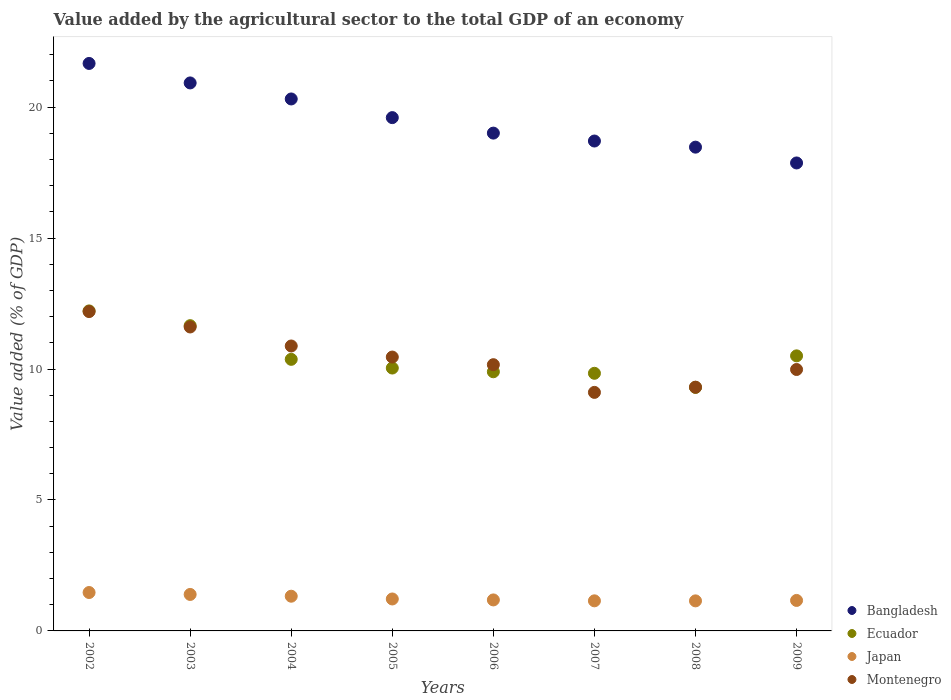Is the number of dotlines equal to the number of legend labels?
Give a very brief answer. Yes. What is the value added by the agricultural sector to the total GDP in Montenegro in 2008?
Your response must be concise. 9.31. Across all years, what is the maximum value added by the agricultural sector to the total GDP in Montenegro?
Keep it short and to the point. 12.19. Across all years, what is the minimum value added by the agricultural sector to the total GDP in Montenegro?
Keep it short and to the point. 9.11. In which year was the value added by the agricultural sector to the total GDP in Japan minimum?
Ensure brevity in your answer.  2008. What is the total value added by the agricultural sector to the total GDP in Montenegro in the graph?
Offer a terse response. 83.7. What is the difference between the value added by the agricultural sector to the total GDP in Montenegro in 2003 and that in 2006?
Ensure brevity in your answer.  1.44. What is the difference between the value added by the agricultural sector to the total GDP in Montenegro in 2004 and the value added by the agricultural sector to the total GDP in Bangladesh in 2009?
Keep it short and to the point. -6.99. What is the average value added by the agricultural sector to the total GDP in Ecuador per year?
Your answer should be very brief. 10.48. In the year 2008, what is the difference between the value added by the agricultural sector to the total GDP in Bangladesh and value added by the agricultural sector to the total GDP in Japan?
Your answer should be very brief. 17.32. What is the ratio of the value added by the agricultural sector to the total GDP in Montenegro in 2002 to that in 2006?
Make the answer very short. 1.2. Is the difference between the value added by the agricultural sector to the total GDP in Bangladesh in 2002 and 2009 greater than the difference between the value added by the agricultural sector to the total GDP in Japan in 2002 and 2009?
Give a very brief answer. Yes. What is the difference between the highest and the second highest value added by the agricultural sector to the total GDP in Japan?
Make the answer very short. 0.07. What is the difference between the highest and the lowest value added by the agricultural sector to the total GDP in Montenegro?
Offer a terse response. 3.09. In how many years, is the value added by the agricultural sector to the total GDP in Ecuador greater than the average value added by the agricultural sector to the total GDP in Ecuador taken over all years?
Your answer should be compact. 3. Is the sum of the value added by the agricultural sector to the total GDP in Bangladesh in 2003 and 2004 greater than the maximum value added by the agricultural sector to the total GDP in Japan across all years?
Your response must be concise. Yes. Is it the case that in every year, the sum of the value added by the agricultural sector to the total GDP in Bangladesh and value added by the agricultural sector to the total GDP in Montenegro  is greater than the sum of value added by the agricultural sector to the total GDP in Ecuador and value added by the agricultural sector to the total GDP in Japan?
Offer a terse response. Yes. Does the value added by the agricultural sector to the total GDP in Ecuador monotonically increase over the years?
Provide a short and direct response. No. How many dotlines are there?
Give a very brief answer. 4. What is the difference between two consecutive major ticks on the Y-axis?
Keep it short and to the point. 5. Does the graph contain grids?
Ensure brevity in your answer.  No. Where does the legend appear in the graph?
Provide a succinct answer. Bottom right. How many legend labels are there?
Your answer should be very brief. 4. How are the legend labels stacked?
Provide a short and direct response. Vertical. What is the title of the graph?
Make the answer very short. Value added by the agricultural sector to the total GDP of an economy. What is the label or title of the X-axis?
Your response must be concise. Years. What is the label or title of the Y-axis?
Ensure brevity in your answer.  Value added (% of GDP). What is the Value added (% of GDP) in Bangladesh in 2002?
Your answer should be compact. 21.67. What is the Value added (% of GDP) of Ecuador in 2002?
Keep it short and to the point. 12.22. What is the Value added (% of GDP) in Japan in 2002?
Offer a terse response. 1.47. What is the Value added (% of GDP) in Montenegro in 2002?
Keep it short and to the point. 12.19. What is the Value added (% of GDP) of Bangladesh in 2003?
Make the answer very short. 20.92. What is the Value added (% of GDP) in Ecuador in 2003?
Make the answer very short. 11.66. What is the Value added (% of GDP) of Japan in 2003?
Your response must be concise. 1.39. What is the Value added (% of GDP) in Montenegro in 2003?
Ensure brevity in your answer.  11.61. What is the Value added (% of GDP) in Bangladesh in 2004?
Offer a very short reply. 20.31. What is the Value added (% of GDP) of Ecuador in 2004?
Ensure brevity in your answer.  10.37. What is the Value added (% of GDP) in Japan in 2004?
Offer a very short reply. 1.33. What is the Value added (% of GDP) of Montenegro in 2004?
Ensure brevity in your answer.  10.88. What is the Value added (% of GDP) of Bangladesh in 2005?
Ensure brevity in your answer.  19.6. What is the Value added (% of GDP) of Ecuador in 2005?
Ensure brevity in your answer.  10.04. What is the Value added (% of GDP) in Japan in 2005?
Keep it short and to the point. 1.22. What is the Value added (% of GDP) of Montenegro in 2005?
Offer a very short reply. 10.46. What is the Value added (% of GDP) in Bangladesh in 2006?
Offer a very short reply. 19.01. What is the Value added (% of GDP) of Ecuador in 2006?
Keep it short and to the point. 9.9. What is the Value added (% of GDP) in Japan in 2006?
Make the answer very short. 1.18. What is the Value added (% of GDP) of Montenegro in 2006?
Your answer should be very brief. 10.17. What is the Value added (% of GDP) of Bangladesh in 2007?
Your response must be concise. 18.71. What is the Value added (% of GDP) of Ecuador in 2007?
Keep it short and to the point. 9.84. What is the Value added (% of GDP) of Japan in 2007?
Your answer should be very brief. 1.15. What is the Value added (% of GDP) in Montenegro in 2007?
Provide a succinct answer. 9.11. What is the Value added (% of GDP) of Bangladesh in 2008?
Offer a terse response. 18.47. What is the Value added (% of GDP) of Ecuador in 2008?
Offer a very short reply. 9.3. What is the Value added (% of GDP) in Japan in 2008?
Provide a succinct answer. 1.15. What is the Value added (% of GDP) in Montenegro in 2008?
Keep it short and to the point. 9.31. What is the Value added (% of GDP) in Bangladesh in 2009?
Your answer should be compact. 17.87. What is the Value added (% of GDP) in Ecuador in 2009?
Provide a short and direct response. 10.5. What is the Value added (% of GDP) in Japan in 2009?
Offer a very short reply. 1.16. What is the Value added (% of GDP) of Montenegro in 2009?
Your answer should be compact. 9.98. Across all years, what is the maximum Value added (% of GDP) of Bangladesh?
Make the answer very short. 21.67. Across all years, what is the maximum Value added (% of GDP) of Ecuador?
Ensure brevity in your answer.  12.22. Across all years, what is the maximum Value added (% of GDP) in Japan?
Offer a terse response. 1.47. Across all years, what is the maximum Value added (% of GDP) in Montenegro?
Offer a very short reply. 12.19. Across all years, what is the minimum Value added (% of GDP) of Bangladesh?
Offer a very short reply. 17.87. Across all years, what is the minimum Value added (% of GDP) of Ecuador?
Offer a terse response. 9.3. Across all years, what is the minimum Value added (% of GDP) in Japan?
Make the answer very short. 1.15. Across all years, what is the minimum Value added (% of GDP) of Montenegro?
Provide a short and direct response. 9.11. What is the total Value added (% of GDP) in Bangladesh in the graph?
Provide a short and direct response. 156.56. What is the total Value added (% of GDP) in Ecuador in the graph?
Your answer should be compact. 83.82. What is the total Value added (% of GDP) in Japan in the graph?
Ensure brevity in your answer.  10.05. What is the total Value added (% of GDP) of Montenegro in the graph?
Offer a terse response. 83.7. What is the difference between the Value added (% of GDP) in Bangladesh in 2002 and that in 2003?
Give a very brief answer. 0.74. What is the difference between the Value added (% of GDP) in Ecuador in 2002 and that in 2003?
Provide a short and direct response. 0.56. What is the difference between the Value added (% of GDP) of Japan in 2002 and that in 2003?
Your answer should be compact. 0.07. What is the difference between the Value added (% of GDP) in Montenegro in 2002 and that in 2003?
Ensure brevity in your answer.  0.59. What is the difference between the Value added (% of GDP) of Bangladesh in 2002 and that in 2004?
Provide a succinct answer. 1.36. What is the difference between the Value added (% of GDP) in Ecuador in 2002 and that in 2004?
Provide a succinct answer. 1.85. What is the difference between the Value added (% of GDP) of Japan in 2002 and that in 2004?
Provide a short and direct response. 0.14. What is the difference between the Value added (% of GDP) of Montenegro in 2002 and that in 2004?
Your response must be concise. 1.31. What is the difference between the Value added (% of GDP) of Bangladesh in 2002 and that in 2005?
Keep it short and to the point. 2.07. What is the difference between the Value added (% of GDP) of Ecuador in 2002 and that in 2005?
Provide a short and direct response. 2.18. What is the difference between the Value added (% of GDP) of Japan in 2002 and that in 2005?
Offer a terse response. 0.25. What is the difference between the Value added (% of GDP) of Montenegro in 2002 and that in 2005?
Provide a succinct answer. 1.74. What is the difference between the Value added (% of GDP) in Bangladesh in 2002 and that in 2006?
Keep it short and to the point. 2.66. What is the difference between the Value added (% of GDP) of Ecuador in 2002 and that in 2006?
Your answer should be very brief. 2.32. What is the difference between the Value added (% of GDP) in Japan in 2002 and that in 2006?
Offer a very short reply. 0.28. What is the difference between the Value added (% of GDP) in Montenegro in 2002 and that in 2006?
Give a very brief answer. 2.03. What is the difference between the Value added (% of GDP) in Bangladesh in 2002 and that in 2007?
Your answer should be compact. 2.96. What is the difference between the Value added (% of GDP) of Ecuador in 2002 and that in 2007?
Provide a succinct answer. 2.38. What is the difference between the Value added (% of GDP) of Japan in 2002 and that in 2007?
Your response must be concise. 0.32. What is the difference between the Value added (% of GDP) of Montenegro in 2002 and that in 2007?
Provide a succinct answer. 3.09. What is the difference between the Value added (% of GDP) in Bangladesh in 2002 and that in 2008?
Your answer should be compact. 3.2. What is the difference between the Value added (% of GDP) in Ecuador in 2002 and that in 2008?
Offer a terse response. 2.92. What is the difference between the Value added (% of GDP) of Japan in 2002 and that in 2008?
Ensure brevity in your answer.  0.32. What is the difference between the Value added (% of GDP) in Montenegro in 2002 and that in 2008?
Your answer should be compact. 2.89. What is the difference between the Value added (% of GDP) of Bangladesh in 2002 and that in 2009?
Your answer should be compact. 3.8. What is the difference between the Value added (% of GDP) in Ecuador in 2002 and that in 2009?
Offer a very short reply. 1.72. What is the difference between the Value added (% of GDP) in Japan in 2002 and that in 2009?
Make the answer very short. 0.3. What is the difference between the Value added (% of GDP) of Montenegro in 2002 and that in 2009?
Your answer should be very brief. 2.21. What is the difference between the Value added (% of GDP) in Bangladesh in 2003 and that in 2004?
Provide a short and direct response. 0.61. What is the difference between the Value added (% of GDP) of Ecuador in 2003 and that in 2004?
Make the answer very short. 1.29. What is the difference between the Value added (% of GDP) of Japan in 2003 and that in 2004?
Your response must be concise. 0.07. What is the difference between the Value added (% of GDP) of Montenegro in 2003 and that in 2004?
Your answer should be compact. 0.73. What is the difference between the Value added (% of GDP) in Bangladesh in 2003 and that in 2005?
Ensure brevity in your answer.  1.32. What is the difference between the Value added (% of GDP) in Ecuador in 2003 and that in 2005?
Offer a terse response. 1.62. What is the difference between the Value added (% of GDP) of Japan in 2003 and that in 2005?
Ensure brevity in your answer.  0.17. What is the difference between the Value added (% of GDP) of Montenegro in 2003 and that in 2005?
Offer a very short reply. 1.15. What is the difference between the Value added (% of GDP) of Bangladesh in 2003 and that in 2006?
Your response must be concise. 1.92. What is the difference between the Value added (% of GDP) in Ecuador in 2003 and that in 2006?
Provide a short and direct response. 1.76. What is the difference between the Value added (% of GDP) in Japan in 2003 and that in 2006?
Your answer should be very brief. 0.21. What is the difference between the Value added (% of GDP) in Montenegro in 2003 and that in 2006?
Provide a succinct answer. 1.44. What is the difference between the Value added (% of GDP) of Bangladesh in 2003 and that in 2007?
Offer a very short reply. 2.22. What is the difference between the Value added (% of GDP) in Ecuador in 2003 and that in 2007?
Keep it short and to the point. 1.82. What is the difference between the Value added (% of GDP) in Japan in 2003 and that in 2007?
Your response must be concise. 0.24. What is the difference between the Value added (% of GDP) in Montenegro in 2003 and that in 2007?
Keep it short and to the point. 2.5. What is the difference between the Value added (% of GDP) of Bangladesh in 2003 and that in 2008?
Provide a short and direct response. 2.45. What is the difference between the Value added (% of GDP) in Ecuador in 2003 and that in 2008?
Your response must be concise. 2.36. What is the difference between the Value added (% of GDP) in Japan in 2003 and that in 2008?
Ensure brevity in your answer.  0.25. What is the difference between the Value added (% of GDP) of Montenegro in 2003 and that in 2008?
Your response must be concise. 2.3. What is the difference between the Value added (% of GDP) in Bangladesh in 2003 and that in 2009?
Keep it short and to the point. 3.06. What is the difference between the Value added (% of GDP) in Ecuador in 2003 and that in 2009?
Ensure brevity in your answer.  1.15. What is the difference between the Value added (% of GDP) of Japan in 2003 and that in 2009?
Provide a succinct answer. 0.23. What is the difference between the Value added (% of GDP) of Montenegro in 2003 and that in 2009?
Ensure brevity in your answer.  1.62. What is the difference between the Value added (% of GDP) in Bangladesh in 2004 and that in 2005?
Offer a terse response. 0.71. What is the difference between the Value added (% of GDP) in Ecuador in 2004 and that in 2005?
Make the answer very short. 0.33. What is the difference between the Value added (% of GDP) of Japan in 2004 and that in 2005?
Give a very brief answer. 0.11. What is the difference between the Value added (% of GDP) of Montenegro in 2004 and that in 2005?
Offer a terse response. 0.42. What is the difference between the Value added (% of GDP) in Bangladesh in 2004 and that in 2006?
Provide a short and direct response. 1.3. What is the difference between the Value added (% of GDP) of Ecuador in 2004 and that in 2006?
Your response must be concise. 0.47. What is the difference between the Value added (% of GDP) of Japan in 2004 and that in 2006?
Your answer should be compact. 0.14. What is the difference between the Value added (% of GDP) in Montenegro in 2004 and that in 2006?
Your response must be concise. 0.71. What is the difference between the Value added (% of GDP) in Bangladesh in 2004 and that in 2007?
Keep it short and to the point. 1.61. What is the difference between the Value added (% of GDP) of Ecuador in 2004 and that in 2007?
Provide a short and direct response. 0.53. What is the difference between the Value added (% of GDP) of Japan in 2004 and that in 2007?
Ensure brevity in your answer.  0.18. What is the difference between the Value added (% of GDP) in Montenegro in 2004 and that in 2007?
Ensure brevity in your answer.  1.77. What is the difference between the Value added (% of GDP) of Bangladesh in 2004 and that in 2008?
Offer a terse response. 1.84. What is the difference between the Value added (% of GDP) of Ecuador in 2004 and that in 2008?
Your answer should be compact. 1.07. What is the difference between the Value added (% of GDP) of Japan in 2004 and that in 2008?
Make the answer very short. 0.18. What is the difference between the Value added (% of GDP) in Montenegro in 2004 and that in 2008?
Your answer should be very brief. 1.57. What is the difference between the Value added (% of GDP) of Bangladesh in 2004 and that in 2009?
Your answer should be very brief. 2.44. What is the difference between the Value added (% of GDP) in Ecuador in 2004 and that in 2009?
Your response must be concise. -0.13. What is the difference between the Value added (% of GDP) in Japan in 2004 and that in 2009?
Ensure brevity in your answer.  0.16. What is the difference between the Value added (% of GDP) in Montenegro in 2004 and that in 2009?
Ensure brevity in your answer.  0.9. What is the difference between the Value added (% of GDP) of Bangladesh in 2005 and that in 2006?
Offer a very short reply. 0.59. What is the difference between the Value added (% of GDP) of Ecuador in 2005 and that in 2006?
Your answer should be compact. 0.14. What is the difference between the Value added (% of GDP) in Japan in 2005 and that in 2006?
Your answer should be compact. 0.04. What is the difference between the Value added (% of GDP) in Montenegro in 2005 and that in 2006?
Ensure brevity in your answer.  0.29. What is the difference between the Value added (% of GDP) of Bangladesh in 2005 and that in 2007?
Provide a short and direct response. 0.89. What is the difference between the Value added (% of GDP) of Ecuador in 2005 and that in 2007?
Provide a succinct answer. 0.2. What is the difference between the Value added (% of GDP) in Japan in 2005 and that in 2007?
Your response must be concise. 0.07. What is the difference between the Value added (% of GDP) of Montenegro in 2005 and that in 2007?
Give a very brief answer. 1.35. What is the difference between the Value added (% of GDP) in Bangladesh in 2005 and that in 2008?
Give a very brief answer. 1.13. What is the difference between the Value added (% of GDP) in Ecuador in 2005 and that in 2008?
Keep it short and to the point. 0.74. What is the difference between the Value added (% of GDP) of Japan in 2005 and that in 2008?
Provide a succinct answer. 0.07. What is the difference between the Value added (% of GDP) in Montenegro in 2005 and that in 2008?
Ensure brevity in your answer.  1.15. What is the difference between the Value added (% of GDP) of Bangladesh in 2005 and that in 2009?
Keep it short and to the point. 1.73. What is the difference between the Value added (% of GDP) of Ecuador in 2005 and that in 2009?
Ensure brevity in your answer.  -0.47. What is the difference between the Value added (% of GDP) in Japan in 2005 and that in 2009?
Your response must be concise. 0.06. What is the difference between the Value added (% of GDP) in Montenegro in 2005 and that in 2009?
Give a very brief answer. 0.47. What is the difference between the Value added (% of GDP) in Bangladesh in 2006 and that in 2007?
Keep it short and to the point. 0.3. What is the difference between the Value added (% of GDP) in Ecuador in 2006 and that in 2007?
Your response must be concise. 0.06. What is the difference between the Value added (% of GDP) of Japan in 2006 and that in 2007?
Your answer should be compact. 0.03. What is the difference between the Value added (% of GDP) of Montenegro in 2006 and that in 2007?
Give a very brief answer. 1.06. What is the difference between the Value added (% of GDP) of Bangladesh in 2006 and that in 2008?
Provide a short and direct response. 0.54. What is the difference between the Value added (% of GDP) of Ecuador in 2006 and that in 2008?
Provide a short and direct response. 0.6. What is the difference between the Value added (% of GDP) in Japan in 2006 and that in 2008?
Give a very brief answer. 0.04. What is the difference between the Value added (% of GDP) of Montenegro in 2006 and that in 2008?
Your response must be concise. 0.86. What is the difference between the Value added (% of GDP) of Bangladesh in 2006 and that in 2009?
Your answer should be compact. 1.14. What is the difference between the Value added (% of GDP) of Ecuador in 2006 and that in 2009?
Offer a terse response. -0.61. What is the difference between the Value added (% of GDP) in Japan in 2006 and that in 2009?
Ensure brevity in your answer.  0.02. What is the difference between the Value added (% of GDP) in Montenegro in 2006 and that in 2009?
Offer a terse response. 0.18. What is the difference between the Value added (% of GDP) in Bangladesh in 2007 and that in 2008?
Your answer should be very brief. 0.23. What is the difference between the Value added (% of GDP) in Ecuador in 2007 and that in 2008?
Make the answer very short. 0.54. What is the difference between the Value added (% of GDP) in Japan in 2007 and that in 2008?
Ensure brevity in your answer.  0. What is the difference between the Value added (% of GDP) of Montenegro in 2007 and that in 2008?
Offer a terse response. -0.2. What is the difference between the Value added (% of GDP) of Bangladesh in 2007 and that in 2009?
Give a very brief answer. 0.84. What is the difference between the Value added (% of GDP) of Ecuador in 2007 and that in 2009?
Make the answer very short. -0.67. What is the difference between the Value added (% of GDP) of Japan in 2007 and that in 2009?
Keep it short and to the point. -0.02. What is the difference between the Value added (% of GDP) in Montenegro in 2007 and that in 2009?
Make the answer very short. -0.87. What is the difference between the Value added (% of GDP) of Bangladesh in 2008 and that in 2009?
Ensure brevity in your answer.  0.6. What is the difference between the Value added (% of GDP) in Ecuador in 2008 and that in 2009?
Give a very brief answer. -1.2. What is the difference between the Value added (% of GDP) of Japan in 2008 and that in 2009?
Offer a very short reply. -0.02. What is the difference between the Value added (% of GDP) in Montenegro in 2008 and that in 2009?
Offer a terse response. -0.68. What is the difference between the Value added (% of GDP) of Bangladesh in 2002 and the Value added (% of GDP) of Ecuador in 2003?
Your answer should be very brief. 10.01. What is the difference between the Value added (% of GDP) of Bangladesh in 2002 and the Value added (% of GDP) of Japan in 2003?
Provide a succinct answer. 20.28. What is the difference between the Value added (% of GDP) of Bangladesh in 2002 and the Value added (% of GDP) of Montenegro in 2003?
Keep it short and to the point. 10.06. What is the difference between the Value added (% of GDP) in Ecuador in 2002 and the Value added (% of GDP) in Japan in 2003?
Provide a short and direct response. 10.83. What is the difference between the Value added (% of GDP) of Ecuador in 2002 and the Value added (% of GDP) of Montenegro in 2003?
Your response must be concise. 0.61. What is the difference between the Value added (% of GDP) of Japan in 2002 and the Value added (% of GDP) of Montenegro in 2003?
Your answer should be very brief. -10.14. What is the difference between the Value added (% of GDP) in Bangladesh in 2002 and the Value added (% of GDP) in Ecuador in 2004?
Keep it short and to the point. 11.3. What is the difference between the Value added (% of GDP) in Bangladesh in 2002 and the Value added (% of GDP) in Japan in 2004?
Provide a succinct answer. 20.34. What is the difference between the Value added (% of GDP) in Bangladesh in 2002 and the Value added (% of GDP) in Montenegro in 2004?
Give a very brief answer. 10.79. What is the difference between the Value added (% of GDP) of Ecuador in 2002 and the Value added (% of GDP) of Japan in 2004?
Provide a short and direct response. 10.89. What is the difference between the Value added (% of GDP) of Ecuador in 2002 and the Value added (% of GDP) of Montenegro in 2004?
Make the answer very short. 1.34. What is the difference between the Value added (% of GDP) in Japan in 2002 and the Value added (% of GDP) in Montenegro in 2004?
Ensure brevity in your answer.  -9.41. What is the difference between the Value added (% of GDP) in Bangladesh in 2002 and the Value added (% of GDP) in Ecuador in 2005?
Provide a succinct answer. 11.63. What is the difference between the Value added (% of GDP) of Bangladesh in 2002 and the Value added (% of GDP) of Japan in 2005?
Provide a succinct answer. 20.45. What is the difference between the Value added (% of GDP) in Bangladesh in 2002 and the Value added (% of GDP) in Montenegro in 2005?
Give a very brief answer. 11.21. What is the difference between the Value added (% of GDP) of Ecuador in 2002 and the Value added (% of GDP) of Japan in 2005?
Your answer should be compact. 11. What is the difference between the Value added (% of GDP) in Ecuador in 2002 and the Value added (% of GDP) in Montenegro in 2005?
Offer a very short reply. 1.76. What is the difference between the Value added (% of GDP) in Japan in 2002 and the Value added (% of GDP) in Montenegro in 2005?
Your response must be concise. -8.99. What is the difference between the Value added (% of GDP) in Bangladesh in 2002 and the Value added (% of GDP) in Ecuador in 2006?
Provide a succinct answer. 11.77. What is the difference between the Value added (% of GDP) in Bangladesh in 2002 and the Value added (% of GDP) in Japan in 2006?
Offer a very short reply. 20.48. What is the difference between the Value added (% of GDP) of Bangladesh in 2002 and the Value added (% of GDP) of Montenegro in 2006?
Keep it short and to the point. 11.5. What is the difference between the Value added (% of GDP) of Ecuador in 2002 and the Value added (% of GDP) of Japan in 2006?
Keep it short and to the point. 11.04. What is the difference between the Value added (% of GDP) in Ecuador in 2002 and the Value added (% of GDP) in Montenegro in 2006?
Provide a succinct answer. 2.05. What is the difference between the Value added (% of GDP) of Japan in 2002 and the Value added (% of GDP) of Montenegro in 2006?
Offer a very short reply. -8.7. What is the difference between the Value added (% of GDP) in Bangladesh in 2002 and the Value added (% of GDP) in Ecuador in 2007?
Your answer should be very brief. 11.83. What is the difference between the Value added (% of GDP) in Bangladesh in 2002 and the Value added (% of GDP) in Japan in 2007?
Offer a very short reply. 20.52. What is the difference between the Value added (% of GDP) in Bangladesh in 2002 and the Value added (% of GDP) in Montenegro in 2007?
Your response must be concise. 12.56. What is the difference between the Value added (% of GDP) of Ecuador in 2002 and the Value added (% of GDP) of Japan in 2007?
Ensure brevity in your answer.  11.07. What is the difference between the Value added (% of GDP) of Ecuador in 2002 and the Value added (% of GDP) of Montenegro in 2007?
Give a very brief answer. 3.11. What is the difference between the Value added (% of GDP) of Japan in 2002 and the Value added (% of GDP) of Montenegro in 2007?
Provide a succinct answer. -7.64. What is the difference between the Value added (% of GDP) of Bangladesh in 2002 and the Value added (% of GDP) of Ecuador in 2008?
Offer a terse response. 12.37. What is the difference between the Value added (% of GDP) of Bangladesh in 2002 and the Value added (% of GDP) of Japan in 2008?
Give a very brief answer. 20.52. What is the difference between the Value added (% of GDP) in Bangladesh in 2002 and the Value added (% of GDP) in Montenegro in 2008?
Offer a very short reply. 12.36. What is the difference between the Value added (% of GDP) in Ecuador in 2002 and the Value added (% of GDP) in Japan in 2008?
Offer a terse response. 11.07. What is the difference between the Value added (% of GDP) in Ecuador in 2002 and the Value added (% of GDP) in Montenegro in 2008?
Your answer should be very brief. 2.91. What is the difference between the Value added (% of GDP) in Japan in 2002 and the Value added (% of GDP) in Montenegro in 2008?
Offer a terse response. -7.84. What is the difference between the Value added (% of GDP) of Bangladesh in 2002 and the Value added (% of GDP) of Ecuador in 2009?
Make the answer very short. 11.17. What is the difference between the Value added (% of GDP) of Bangladesh in 2002 and the Value added (% of GDP) of Japan in 2009?
Offer a terse response. 20.5. What is the difference between the Value added (% of GDP) of Bangladesh in 2002 and the Value added (% of GDP) of Montenegro in 2009?
Your answer should be very brief. 11.69. What is the difference between the Value added (% of GDP) of Ecuador in 2002 and the Value added (% of GDP) of Japan in 2009?
Keep it short and to the point. 11.06. What is the difference between the Value added (% of GDP) in Ecuador in 2002 and the Value added (% of GDP) in Montenegro in 2009?
Offer a terse response. 2.24. What is the difference between the Value added (% of GDP) in Japan in 2002 and the Value added (% of GDP) in Montenegro in 2009?
Offer a very short reply. -8.52. What is the difference between the Value added (% of GDP) in Bangladesh in 2003 and the Value added (% of GDP) in Ecuador in 2004?
Make the answer very short. 10.55. What is the difference between the Value added (% of GDP) in Bangladesh in 2003 and the Value added (% of GDP) in Japan in 2004?
Your response must be concise. 19.6. What is the difference between the Value added (% of GDP) of Bangladesh in 2003 and the Value added (% of GDP) of Montenegro in 2004?
Provide a succinct answer. 10.04. What is the difference between the Value added (% of GDP) of Ecuador in 2003 and the Value added (% of GDP) of Japan in 2004?
Offer a very short reply. 10.33. What is the difference between the Value added (% of GDP) in Ecuador in 2003 and the Value added (% of GDP) in Montenegro in 2004?
Provide a short and direct response. 0.78. What is the difference between the Value added (% of GDP) of Japan in 2003 and the Value added (% of GDP) of Montenegro in 2004?
Offer a terse response. -9.49. What is the difference between the Value added (% of GDP) of Bangladesh in 2003 and the Value added (% of GDP) of Ecuador in 2005?
Provide a succinct answer. 10.89. What is the difference between the Value added (% of GDP) in Bangladesh in 2003 and the Value added (% of GDP) in Japan in 2005?
Make the answer very short. 19.7. What is the difference between the Value added (% of GDP) in Bangladesh in 2003 and the Value added (% of GDP) in Montenegro in 2005?
Keep it short and to the point. 10.47. What is the difference between the Value added (% of GDP) in Ecuador in 2003 and the Value added (% of GDP) in Japan in 2005?
Give a very brief answer. 10.44. What is the difference between the Value added (% of GDP) in Ecuador in 2003 and the Value added (% of GDP) in Montenegro in 2005?
Give a very brief answer. 1.2. What is the difference between the Value added (% of GDP) in Japan in 2003 and the Value added (% of GDP) in Montenegro in 2005?
Keep it short and to the point. -9.06. What is the difference between the Value added (% of GDP) in Bangladesh in 2003 and the Value added (% of GDP) in Ecuador in 2006?
Offer a terse response. 11.03. What is the difference between the Value added (% of GDP) of Bangladesh in 2003 and the Value added (% of GDP) of Japan in 2006?
Offer a very short reply. 19.74. What is the difference between the Value added (% of GDP) of Bangladesh in 2003 and the Value added (% of GDP) of Montenegro in 2006?
Keep it short and to the point. 10.76. What is the difference between the Value added (% of GDP) in Ecuador in 2003 and the Value added (% of GDP) in Japan in 2006?
Provide a succinct answer. 10.47. What is the difference between the Value added (% of GDP) of Ecuador in 2003 and the Value added (% of GDP) of Montenegro in 2006?
Your response must be concise. 1.49. What is the difference between the Value added (% of GDP) of Japan in 2003 and the Value added (% of GDP) of Montenegro in 2006?
Make the answer very short. -8.77. What is the difference between the Value added (% of GDP) of Bangladesh in 2003 and the Value added (% of GDP) of Ecuador in 2007?
Give a very brief answer. 11.09. What is the difference between the Value added (% of GDP) of Bangladesh in 2003 and the Value added (% of GDP) of Japan in 2007?
Ensure brevity in your answer.  19.78. What is the difference between the Value added (% of GDP) of Bangladesh in 2003 and the Value added (% of GDP) of Montenegro in 2007?
Ensure brevity in your answer.  11.82. What is the difference between the Value added (% of GDP) of Ecuador in 2003 and the Value added (% of GDP) of Japan in 2007?
Provide a short and direct response. 10.51. What is the difference between the Value added (% of GDP) of Ecuador in 2003 and the Value added (% of GDP) of Montenegro in 2007?
Give a very brief answer. 2.55. What is the difference between the Value added (% of GDP) of Japan in 2003 and the Value added (% of GDP) of Montenegro in 2007?
Keep it short and to the point. -7.72. What is the difference between the Value added (% of GDP) in Bangladesh in 2003 and the Value added (% of GDP) in Ecuador in 2008?
Your answer should be very brief. 11.63. What is the difference between the Value added (% of GDP) of Bangladesh in 2003 and the Value added (% of GDP) of Japan in 2008?
Your answer should be very brief. 19.78. What is the difference between the Value added (% of GDP) of Bangladesh in 2003 and the Value added (% of GDP) of Montenegro in 2008?
Ensure brevity in your answer.  11.62. What is the difference between the Value added (% of GDP) in Ecuador in 2003 and the Value added (% of GDP) in Japan in 2008?
Make the answer very short. 10.51. What is the difference between the Value added (% of GDP) of Ecuador in 2003 and the Value added (% of GDP) of Montenegro in 2008?
Offer a terse response. 2.35. What is the difference between the Value added (% of GDP) in Japan in 2003 and the Value added (% of GDP) in Montenegro in 2008?
Offer a terse response. -7.91. What is the difference between the Value added (% of GDP) in Bangladesh in 2003 and the Value added (% of GDP) in Ecuador in 2009?
Offer a very short reply. 10.42. What is the difference between the Value added (% of GDP) of Bangladesh in 2003 and the Value added (% of GDP) of Japan in 2009?
Give a very brief answer. 19.76. What is the difference between the Value added (% of GDP) in Bangladesh in 2003 and the Value added (% of GDP) in Montenegro in 2009?
Your response must be concise. 10.94. What is the difference between the Value added (% of GDP) of Ecuador in 2003 and the Value added (% of GDP) of Japan in 2009?
Your answer should be compact. 10.49. What is the difference between the Value added (% of GDP) in Ecuador in 2003 and the Value added (% of GDP) in Montenegro in 2009?
Offer a very short reply. 1.67. What is the difference between the Value added (% of GDP) in Japan in 2003 and the Value added (% of GDP) in Montenegro in 2009?
Your answer should be very brief. -8.59. What is the difference between the Value added (% of GDP) in Bangladesh in 2004 and the Value added (% of GDP) in Ecuador in 2005?
Make the answer very short. 10.27. What is the difference between the Value added (% of GDP) of Bangladesh in 2004 and the Value added (% of GDP) of Japan in 2005?
Your response must be concise. 19.09. What is the difference between the Value added (% of GDP) of Bangladesh in 2004 and the Value added (% of GDP) of Montenegro in 2005?
Keep it short and to the point. 9.86. What is the difference between the Value added (% of GDP) of Ecuador in 2004 and the Value added (% of GDP) of Japan in 2005?
Keep it short and to the point. 9.15. What is the difference between the Value added (% of GDP) of Ecuador in 2004 and the Value added (% of GDP) of Montenegro in 2005?
Offer a terse response. -0.09. What is the difference between the Value added (% of GDP) in Japan in 2004 and the Value added (% of GDP) in Montenegro in 2005?
Your response must be concise. -9.13. What is the difference between the Value added (% of GDP) of Bangladesh in 2004 and the Value added (% of GDP) of Ecuador in 2006?
Provide a succinct answer. 10.42. What is the difference between the Value added (% of GDP) of Bangladesh in 2004 and the Value added (% of GDP) of Japan in 2006?
Ensure brevity in your answer.  19.13. What is the difference between the Value added (% of GDP) of Bangladesh in 2004 and the Value added (% of GDP) of Montenegro in 2006?
Your answer should be very brief. 10.15. What is the difference between the Value added (% of GDP) in Ecuador in 2004 and the Value added (% of GDP) in Japan in 2006?
Give a very brief answer. 9.19. What is the difference between the Value added (% of GDP) in Ecuador in 2004 and the Value added (% of GDP) in Montenegro in 2006?
Keep it short and to the point. 0.2. What is the difference between the Value added (% of GDP) of Japan in 2004 and the Value added (% of GDP) of Montenegro in 2006?
Keep it short and to the point. -8.84. What is the difference between the Value added (% of GDP) in Bangladesh in 2004 and the Value added (% of GDP) in Ecuador in 2007?
Make the answer very short. 10.48. What is the difference between the Value added (% of GDP) in Bangladesh in 2004 and the Value added (% of GDP) in Japan in 2007?
Provide a short and direct response. 19.16. What is the difference between the Value added (% of GDP) in Bangladesh in 2004 and the Value added (% of GDP) in Montenegro in 2007?
Offer a very short reply. 11.2. What is the difference between the Value added (% of GDP) of Ecuador in 2004 and the Value added (% of GDP) of Japan in 2007?
Your answer should be very brief. 9.22. What is the difference between the Value added (% of GDP) of Ecuador in 2004 and the Value added (% of GDP) of Montenegro in 2007?
Offer a terse response. 1.26. What is the difference between the Value added (% of GDP) in Japan in 2004 and the Value added (% of GDP) in Montenegro in 2007?
Offer a terse response. -7.78. What is the difference between the Value added (% of GDP) in Bangladesh in 2004 and the Value added (% of GDP) in Ecuador in 2008?
Offer a terse response. 11.01. What is the difference between the Value added (% of GDP) in Bangladesh in 2004 and the Value added (% of GDP) in Japan in 2008?
Your answer should be compact. 19.17. What is the difference between the Value added (% of GDP) in Bangladesh in 2004 and the Value added (% of GDP) in Montenegro in 2008?
Provide a short and direct response. 11.01. What is the difference between the Value added (% of GDP) of Ecuador in 2004 and the Value added (% of GDP) of Japan in 2008?
Provide a succinct answer. 9.22. What is the difference between the Value added (% of GDP) in Ecuador in 2004 and the Value added (% of GDP) in Montenegro in 2008?
Provide a short and direct response. 1.06. What is the difference between the Value added (% of GDP) in Japan in 2004 and the Value added (% of GDP) in Montenegro in 2008?
Your answer should be very brief. -7.98. What is the difference between the Value added (% of GDP) of Bangladesh in 2004 and the Value added (% of GDP) of Ecuador in 2009?
Offer a terse response. 9.81. What is the difference between the Value added (% of GDP) of Bangladesh in 2004 and the Value added (% of GDP) of Japan in 2009?
Offer a terse response. 19.15. What is the difference between the Value added (% of GDP) of Bangladesh in 2004 and the Value added (% of GDP) of Montenegro in 2009?
Provide a succinct answer. 10.33. What is the difference between the Value added (% of GDP) in Ecuador in 2004 and the Value added (% of GDP) in Japan in 2009?
Keep it short and to the point. 9.21. What is the difference between the Value added (% of GDP) of Ecuador in 2004 and the Value added (% of GDP) of Montenegro in 2009?
Your answer should be very brief. 0.39. What is the difference between the Value added (% of GDP) in Japan in 2004 and the Value added (% of GDP) in Montenegro in 2009?
Keep it short and to the point. -8.66. What is the difference between the Value added (% of GDP) of Bangladesh in 2005 and the Value added (% of GDP) of Ecuador in 2006?
Your answer should be compact. 9.7. What is the difference between the Value added (% of GDP) of Bangladesh in 2005 and the Value added (% of GDP) of Japan in 2006?
Make the answer very short. 18.42. What is the difference between the Value added (% of GDP) of Bangladesh in 2005 and the Value added (% of GDP) of Montenegro in 2006?
Offer a terse response. 9.43. What is the difference between the Value added (% of GDP) in Ecuador in 2005 and the Value added (% of GDP) in Japan in 2006?
Make the answer very short. 8.85. What is the difference between the Value added (% of GDP) in Ecuador in 2005 and the Value added (% of GDP) in Montenegro in 2006?
Offer a terse response. -0.13. What is the difference between the Value added (% of GDP) of Japan in 2005 and the Value added (% of GDP) of Montenegro in 2006?
Your answer should be very brief. -8.95. What is the difference between the Value added (% of GDP) of Bangladesh in 2005 and the Value added (% of GDP) of Ecuador in 2007?
Give a very brief answer. 9.76. What is the difference between the Value added (% of GDP) of Bangladesh in 2005 and the Value added (% of GDP) of Japan in 2007?
Give a very brief answer. 18.45. What is the difference between the Value added (% of GDP) in Bangladesh in 2005 and the Value added (% of GDP) in Montenegro in 2007?
Offer a very short reply. 10.49. What is the difference between the Value added (% of GDP) of Ecuador in 2005 and the Value added (% of GDP) of Japan in 2007?
Offer a very short reply. 8.89. What is the difference between the Value added (% of GDP) in Ecuador in 2005 and the Value added (% of GDP) in Montenegro in 2007?
Your response must be concise. 0.93. What is the difference between the Value added (% of GDP) in Japan in 2005 and the Value added (% of GDP) in Montenegro in 2007?
Your answer should be compact. -7.89. What is the difference between the Value added (% of GDP) in Bangladesh in 2005 and the Value added (% of GDP) in Ecuador in 2008?
Offer a very short reply. 10.3. What is the difference between the Value added (% of GDP) in Bangladesh in 2005 and the Value added (% of GDP) in Japan in 2008?
Your answer should be very brief. 18.45. What is the difference between the Value added (% of GDP) in Bangladesh in 2005 and the Value added (% of GDP) in Montenegro in 2008?
Ensure brevity in your answer.  10.29. What is the difference between the Value added (% of GDP) of Ecuador in 2005 and the Value added (% of GDP) of Japan in 2008?
Give a very brief answer. 8.89. What is the difference between the Value added (% of GDP) in Ecuador in 2005 and the Value added (% of GDP) in Montenegro in 2008?
Offer a very short reply. 0.73. What is the difference between the Value added (% of GDP) of Japan in 2005 and the Value added (% of GDP) of Montenegro in 2008?
Give a very brief answer. -8.09. What is the difference between the Value added (% of GDP) of Bangladesh in 2005 and the Value added (% of GDP) of Ecuador in 2009?
Ensure brevity in your answer.  9.1. What is the difference between the Value added (% of GDP) of Bangladesh in 2005 and the Value added (% of GDP) of Japan in 2009?
Your answer should be compact. 18.44. What is the difference between the Value added (% of GDP) in Bangladesh in 2005 and the Value added (% of GDP) in Montenegro in 2009?
Keep it short and to the point. 9.62. What is the difference between the Value added (% of GDP) of Ecuador in 2005 and the Value added (% of GDP) of Japan in 2009?
Your answer should be compact. 8.87. What is the difference between the Value added (% of GDP) of Ecuador in 2005 and the Value added (% of GDP) of Montenegro in 2009?
Provide a short and direct response. 0.06. What is the difference between the Value added (% of GDP) of Japan in 2005 and the Value added (% of GDP) of Montenegro in 2009?
Your response must be concise. -8.76. What is the difference between the Value added (% of GDP) of Bangladesh in 2006 and the Value added (% of GDP) of Ecuador in 2007?
Offer a terse response. 9.17. What is the difference between the Value added (% of GDP) in Bangladesh in 2006 and the Value added (% of GDP) in Japan in 2007?
Provide a short and direct response. 17.86. What is the difference between the Value added (% of GDP) in Ecuador in 2006 and the Value added (% of GDP) in Japan in 2007?
Your response must be concise. 8.75. What is the difference between the Value added (% of GDP) in Ecuador in 2006 and the Value added (% of GDP) in Montenegro in 2007?
Provide a succinct answer. 0.79. What is the difference between the Value added (% of GDP) in Japan in 2006 and the Value added (% of GDP) in Montenegro in 2007?
Your answer should be compact. -7.92. What is the difference between the Value added (% of GDP) in Bangladesh in 2006 and the Value added (% of GDP) in Ecuador in 2008?
Ensure brevity in your answer.  9.71. What is the difference between the Value added (% of GDP) in Bangladesh in 2006 and the Value added (% of GDP) in Japan in 2008?
Provide a short and direct response. 17.86. What is the difference between the Value added (% of GDP) in Bangladesh in 2006 and the Value added (% of GDP) in Montenegro in 2008?
Give a very brief answer. 9.7. What is the difference between the Value added (% of GDP) of Ecuador in 2006 and the Value added (% of GDP) of Japan in 2008?
Keep it short and to the point. 8.75. What is the difference between the Value added (% of GDP) of Ecuador in 2006 and the Value added (% of GDP) of Montenegro in 2008?
Make the answer very short. 0.59. What is the difference between the Value added (% of GDP) in Japan in 2006 and the Value added (% of GDP) in Montenegro in 2008?
Give a very brief answer. -8.12. What is the difference between the Value added (% of GDP) in Bangladesh in 2006 and the Value added (% of GDP) in Ecuador in 2009?
Offer a very short reply. 8.51. What is the difference between the Value added (% of GDP) of Bangladesh in 2006 and the Value added (% of GDP) of Japan in 2009?
Your response must be concise. 17.84. What is the difference between the Value added (% of GDP) in Bangladesh in 2006 and the Value added (% of GDP) in Montenegro in 2009?
Your answer should be very brief. 9.03. What is the difference between the Value added (% of GDP) in Ecuador in 2006 and the Value added (% of GDP) in Japan in 2009?
Your response must be concise. 8.73. What is the difference between the Value added (% of GDP) in Ecuador in 2006 and the Value added (% of GDP) in Montenegro in 2009?
Offer a very short reply. -0.09. What is the difference between the Value added (% of GDP) in Japan in 2006 and the Value added (% of GDP) in Montenegro in 2009?
Offer a terse response. -8.8. What is the difference between the Value added (% of GDP) in Bangladesh in 2007 and the Value added (% of GDP) in Ecuador in 2008?
Make the answer very short. 9.41. What is the difference between the Value added (% of GDP) in Bangladesh in 2007 and the Value added (% of GDP) in Japan in 2008?
Give a very brief answer. 17.56. What is the difference between the Value added (% of GDP) of Bangladesh in 2007 and the Value added (% of GDP) of Montenegro in 2008?
Ensure brevity in your answer.  9.4. What is the difference between the Value added (% of GDP) of Ecuador in 2007 and the Value added (% of GDP) of Japan in 2008?
Make the answer very short. 8.69. What is the difference between the Value added (% of GDP) of Ecuador in 2007 and the Value added (% of GDP) of Montenegro in 2008?
Keep it short and to the point. 0.53. What is the difference between the Value added (% of GDP) in Japan in 2007 and the Value added (% of GDP) in Montenegro in 2008?
Provide a succinct answer. -8.16. What is the difference between the Value added (% of GDP) of Bangladesh in 2007 and the Value added (% of GDP) of Ecuador in 2009?
Keep it short and to the point. 8.2. What is the difference between the Value added (% of GDP) in Bangladesh in 2007 and the Value added (% of GDP) in Japan in 2009?
Give a very brief answer. 17.54. What is the difference between the Value added (% of GDP) of Bangladesh in 2007 and the Value added (% of GDP) of Montenegro in 2009?
Give a very brief answer. 8.72. What is the difference between the Value added (% of GDP) in Ecuador in 2007 and the Value added (% of GDP) in Japan in 2009?
Keep it short and to the point. 8.67. What is the difference between the Value added (% of GDP) in Ecuador in 2007 and the Value added (% of GDP) in Montenegro in 2009?
Your answer should be compact. -0.14. What is the difference between the Value added (% of GDP) of Japan in 2007 and the Value added (% of GDP) of Montenegro in 2009?
Your response must be concise. -8.83. What is the difference between the Value added (% of GDP) of Bangladesh in 2008 and the Value added (% of GDP) of Ecuador in 2009?
Provide a succinct answer. 7.97. What is the difference between the Value added (% of GDP) in Bangladesh in 2008 and the Value added (% of GDP) in Japan in 2009?
Offer a terse response. 17.31. What is the difference between the Value added (% of GDP) of Bangladesh in 2008 and the Value added (% of GDP) of Montenegro in 2009?
Make the answer very short. 8.49. What is the difference between the Value added (% of GDP) of Ecuador in 2008 and the Value added (% of GDP) of Japan in 2009?
Provide a short and direct response. 8.13. What is the difference between the Value added (% of GDP) in Ecuador in 2008 and the Value added (% of GDP) in Montenegro in 2009?
Your answer should be compact. -0.68. What is the difference between the Value added (% of GDP) in Japan in 2008 and the Value added (% of GDP) in Montenegro in 2009?
Your answer should be compact. -8.83. What is the average Value added (% of GDP) of Bangladesh per year?
Keep it short and to the point. 19.57. What is the average Value added (% of GDP) in Ecuador per year?
Your response must be concise. 10.48. What is the average Value added (% of GDP) in Japan per year?
Your response must be concise. 1.26. What is the average Value added (% of GDP) of Montenegro per year?
Offer a very short reply. 10.46. In the year 2002, what is the difference between the Value added (% of GDP) of Bangladesh and Value added (% of GDP) of Ecuador?
Offer a terse response. 9.45. In the year 2002, what is the difference between the Value added (% of GDP) of Bangladesh and Value added (% of GDP) of Japan?
Offer a very short reply. 20.2. In the year 2002, what is the difference between the Value added (% of GDP) in Bangladesh and Value added (% of GDP) in Montenegro?
Your answer should be compact. 9.47. In the year 2002, what is the difference between the Value added (% of GDP) of Ecuador and Value added (% of GDP) of Japan?
Make the answer very short. 10.75. In the year 2002, what is the difference between the Value added (% of GDP) of Ecuador and Value added (% of GDP) of Montenegro?
Your answer should be compact. 0.03. In the year 2002, what is the difference between the Value added (% of GDP) in Japan and Value added (% of GDP) in Montenegro?
Your response must be concise. -10.73. In the year 2003, what is the difference between the Value added (% of GDP) in Bangladesh and Value added (% of GDP) in Ecuador?
Give a very brief answer. 9.27. In the year 2003, what is the difference between the Value added (% of GDP) in Bangladesh and Value added (% of GDP) in Japan?
Your answer should be very brief. 19.53. In the year 2003, what is the difference between the Value added (% of GDP) of Bangladesh and Value added (% of GDP) of Montenegro?
Ensure brevity in your answer.  9.32. In the year 2003, what is the difference between the Value added (% of GDP) in Ecuador and Value added (% of GDP) in Japan?
Your response must be concise. 10.26. In the year 2003, what is the difference between the Value added (% of GDP) in Ecuador and Value added (% of GDP) in Montenegro?
Offer a very short reply. 0.05. In the year 2003, what is the difference between the Value added (% of GDP) of Japan and Value added (% of GDP) of Montenegro?
Your response must be concise. -10.21. In the year 2004, what is the difference between the Value added (% of GDP) of Bangladesh and Value added (% of GDP) of Ecuador?
Your answer should be compact. 9.94. In the year 2004, what is the difference between the Value added (% of GDP) of Bangladesh and Value added (% of GDP) of Japan?
Give a very brief answer. 18.99. In the year 2004, what is the difference between the Value added (% of GDP) in Bangladesh and Value added (% of GDP) in Montenegro?
Make the answer very short. 9.43. In the year 2004, what is the difference between the Value added (% of GDP) of Ecuador and Value added (% of GDP) of Japan?
Keep it short and to the point. 9.05. In the year 2004, what is the difference between the Value added (% of GDP) in Ecuador and Value added (% of GDP) in Montenegro?
Offer a very short reply. -0.51. In the year 2004, what is the difference between the Value added (% of GDP) of Japan and Value added (% of GDP) of Montenegro?
Make the answer very short. -9.55. In the year 2005, what is the difference between the Value added (% of GDP) in Bangladesh and Value added (% of GDP) in Ecuador?
Your response must be concise. 9.56. In the year 2005, what is the difference between the Value added (% of GDP) in Bangladesh and Value added (% of GDP) in Japan?
Your answer should be compact. 18.38. In the year 2005, what is the difference between the Value added (% of GDP) in Bangladesh and Value added (% of GDP) in Montenegro?
Provide a short and direct response. 9.14. In the year 2005, what is the difference between the Value added (% of GDP) of Ecuador and Value added (% of GDP) of Japan?
Give a very brief answer. 8.82. In the year 2005, what is the difference between the Value added (% of GDP) of Ecuador and Value added (% of GDP) of Montenegro?
Provide a succinct answer. -0.42. In the year 2005, what is the difference between the Value added (% of GDP) of Japan and Value added (% of GDP) of Montenegro?
Offer a very short reply. -9.24. In the year 2006, what is the difference between the Value added (% of GDP) in Bangladesh and Value added (% of GDP) in Ecuador?
Ensure brevity in your answer.  9.11. In the year 2006, what is the difference between the Value added (% of GDP) in Bangladesh and Value added (% of GDP) in Japan?
Provide a short and direct response. 17.82. In the year 2006, what is the difference between the Value added (% of GDP) of Bangladesh and Value added (% of GDP) of Montenegro?
Your response must be concise. 8.84. In the year 2006, what is the difference between the Value added (% of GDP) of Ecuador and Value added (% of GDP) of Japan?
Provide a short and direct response. 8.71. In the year 2006, what is the difference between the Value added (% of GDP) of Ecuador and Value added (% of GDP) of Montenegro?
Give a very brief answer. -0.27. In the year 2006, what is the difference between the Value added (% of GDP) of Japan and Value added (% of GDP) of Montenegro?
Give a very brief answer. -8.98. In the year 2007, what is the difference between the Value added (% of GDP) in Bangladesh and Value added (% of GDP) in Ecuador?
Offer a very short reply. 8.87. In the year 2007, what is the difference between the Value added (% of GDP) in Bangladesh and Value added (% of GDP) in Japan?
Keep it short and to the point. 17.56. In the year 2007, what is the difference between the Value added (% of GDP) in Bangladesh and Value added (% of GDP) in Montenegro?
Give a very brief answer. 9.6. In the year 2007, what is the difference between the Value added (% of GDP) of Ecuador and Value added (% of GDP) of Japan?
Give a very brief answer. 8.69. In the year 2007, what is the difference between the Value added (% of GDP) of Ecuador and Value added (% of GDP) of Montenegro?
Your answer should be very brief. 0.73. In the year 2007, what is the difference between the Value added (% of GDP) of Japan and Value added (% of GDP) of Montenegro?
Provide a short and direct response. -7.96. In the year 2008, what is the difference between the Value added (% of GDP) of Bangladesh and Value added (% of GDP) of Ecuador?
Your answer should be compact. 9.17. In the year 2008, what is the difference between the Value added (% of GDP) of Bangladesh and Value added (% of GDP) of Japan?
Your response must be concise. 17.32. In the year 2008, what is the difference between the Value added (% of GDP) of Bangladesh and Value added (% of GDP) of Montenegro?
Make the answer very short. 9.17. In the year 2008, what is the difference between the Value added (% of GDP) of Ecuador and Value added (% of GDP) of Japan?
Offer a very short reply. 8.15. In the year 2008, what is the difference between the Value added (% of GDP) of Ecuador and Value added (% of GDP) of Montenegro?
Provide a short and direct response. -0.01. In the year 2008, what is the difference between the Value added (% of GDP) of Japan and Value added (% of GDP) of Montenegro?
Your response must be concise. -8.16. In the year 2009, what is the difference between the Value added (% of GDP) of Bangladesh and Value added (% of GDP) of Ecuador?
Provide a short and direct response. 7.37. In the year 2009, what is the difference between the Value added (% of GDP) in Bangladesh and Value added (% of GDP) in Japan?
Offer a terse response. 16.7. In the year 2009, what is the difference between the Value added (% of GDP) in Bangladesh and Value added (% of GDP) in Montenegro?
Your response must be concise. 7.89. In the year 2009, what is the difference between the Value added (% of GDP) of Ecuador and Value added (% of GDP) of Japan?
Make the answer very short. 9.34. In the year 2009, what is the difference between the Value added (% of GDP) of Ecuador and Value added (% of GDP) of Montenegro?
Keep it short and to the point. 0.52. In the year 2009, what is the difference between the Value added (% of GDP) in Japan and Value added (% of GDP) in Montenegro?
Offer a very short reply. -8.82. What is the ratio of the Value added (% of GDP) of Bangladesh in 2002 to that in 2003?
Your answer should be compact. 1.04. What is the ratio of the Value added (% of GDP) in Ecuador in 2002 to that in 2003?
Make the answer very short. 1.05. What is the ratio of the Value added (% of GDP) in Japan in 2002 to that in 2003?
Provide a short and direct response. 1.05. What is the ratio of the Value added (% of GDP) in Montenegro in 2002 to that in 2003?
Give a very brief answer. 1.05. What is the ratio of the Value added (% of GDP) of Bangladesh in 2002 to that in 2004?
Your answer should be compact. 1.07. What is the ratio of the Value added (% of GDP) of Ecuador in 2002 to that in 2004?
Offer a terse response. 1.18. What is the ratio of the Value added (% of GDP) of Japan in 2002 to that in 2004?
Give a very brief answer. 1.11. What is the ratio of the Value added (% of GDP) in Montenegro in 2002 to that in 2004?
Offer a very short reply. 1.12. What is the ratio of the Value added (% of GDP) in Bangladesh in 2002 to that in 2005?
Ensure brevity in your answer.  1.11. What is the ratio of the Value added (% of GDP) in Ecuador in 2002 to that in 2005?
Ensure brevity in your answer.  1.22. What is the ratio of the Value added (% of GDP) of Japan in 2002 to that in 2005?
Ensure brevity in your answer.  1.2. What is the ratio of the Value added (% of GDP) of Montenegro in 2002 to that in 2005?
Your answer should be compact. 1.17. What is the ratio of the Value added (% of GDP) in Bangladesh in 2002 to that in 2006?
Your answer should be compact. 1.14. What is the ratio of the Value added (% of GDP) of Ecuador in 2002 to that in 2006?
Your response must be concise. 1.23. What is the ratio of the Value added (% of GDP) in Japan in 2002 to that in 2006?
Keep it short and to the point. 1.24. What is the ratio of the Value added (% of GDP) in Montenegro in 2002 to that in 2006?
Offer a terse response. 1.2. What is the ratio of the Value added (% of GDP) of Bangladesh in 2002 to that in 2007?
Offer a very short reply. 1.16. What is the ratio of the Value added (% of GDP) of Ecuador in 2002 to that in 2007?
Offer a terse response. 1.24. What is the ratio of the Value added (% of GDP) in Japan in 2002 to that in 2007?
Offer a very short reply. 1.28. What is the ratio of the Value added (% of GDP) in Montenegro in 2002 to that in 2007?
Make the answer very short. 1.34. What is the ratio of the Value added (% of GDP) in Bangladesh in 2002 to that in 2008?
Give a very brief answer. 1.17. What is the ratio of the Value added (% of GDP) of Ecuador in 2002 to that in 2008?
Keep it short and to the point. 1.31. What is the ratio of the Value added (% of GDP) of Japan in 2002 to that in 2008?
Your answer should be compact. 1.28. What is the ratio of the Value added (% of GDP) of Montenegro in 2002 to that in 2008?
Provide a succinct answer. 1.31. What is the ratio of the Value added (% of GDP) in Bangladesh in 2002 to that in 2009?
Your answer should be compact. 1.21. What is the ratio of the Value added (% of GDP) of Ecuador in 2002 to that in 2009?
Make the answer very short. 1.16. What is the ratio of the Value added (% of GDP) of Japan in 2002 to that in 2009?
Your answer should be compact. 1.26. What is the ratio of the Value added (% of GDP) of Montenegro in 2002 to that in 2009?
Offer a terse response. 1.22. What is the ratio of the Value added (% of GDP) in Bangladesh in 2003 to that in 2004?
Your response must be concise. 1.03. What is the ratio of the Value added (% of GDP) in Ecuador in 2003 to that in 2004?
Offer a very short reply. 1.12. What is the ratio of the Value added (% of GDP) in Japan in 2003 to that in 2004?
Provide a short and direct response. 1.05. What is the ratio of the Value added (% of GDP) in Montenegro in 2003 to that in 2004?
Give a very brief answer. 1.07. What is the ratio of the Value added (% of GDP) in Bangladesh in 2003 to that in 2005?
Offer a terse response. 1.07. What is the ratio of the Value added (% of GDP) in Ecuador in 2003 to that in 2005?
Offer a terse response. 1.16. What is the ratio of the Value added (% of GDP) in Japan in 2003 to that in 2005?
Your answer should be very brief. 1.14. What is the ratio of the Value added (% of GDP) in Montenegro in 2003 to that in 2005?
Your answer should be compact. 1.11. What is the ratio of the Value added (% of GDP) of Bangladesh in 2003 to that in 2006?
Offer a terse response. 1.1. What is the ratio of the Value added (% of GDP) of Ecuador in 2003 to that in 2006?
Offer a very short reply. 1.18. What is the ratio of the Value added (% of GDP) of Japan in 2003 to that in 2006?
Your answer should be very brief. 1.18. What is the ratio of the Value added (% of GDP) of Montenegro in 2003 to that in 2006?
Provide a short and direct response. 1.14. What is the ratio of the Value added (% of GDP) of Bangladesh in 2003 to that in 2007?
Your answer should be very brief. 1.12. What is the ratio of the Value added (% of GDP) in Ecuador in 2003 to that in 2007?
Make the answer very short. 1.18. What is the ratio of the Value added (% of GDP) of Japan in 2003 to that in 2007?
Give a very brief answer. 1.21. What is the ratio of the Value added (% of GDP) in Montenegro in 2003 to that in 2007?
Your answer should be compact. 1.27. What is the ratio of the Value added (% of GDP) of Bangladesh in 2003 to that in 2008?
Make the answer very short. 1.13. What is the ratio of the Value added (% of GDP) of Ecuador in 2003 to that in 2008?
Offer a very short reply. 1.25. What is the ratio of the Value added (% of GDP) of Japan in 2003 to that in 2008?
Ensure brevity in your answer.  1.21. What is the ratio of the Value added (% of GDP) of Montenegro in 2003 to that in 2008?
Give a very brief answer. 1.25. What is the ratio of the Value added (% of GDP) in Bangladesh in 2003 to that in 2009?
Make the answer very short. 1.17. What is the ratio of the Value added (% of GDP) of Ecuador in 2003 to that in 2009?
Give a very brief answer. 1.11. What is the ratio of the Value added (% of GDP) of Japan in 2003 to that in 2009?
Keep it short and to the point. 1.2. What is the ratio of the Value added (% of GDP) in Montenegro in 2003 to that in 2009?
Make the answer very short. 1.16. What is the ratio of the Value added (% of GDP) in Bangladesh in 2004 to that in 2005?
Provide a short and direct response. 1.04. What is the ratio of the Value added (% of GDP) of Ecuador in 2004 to that in 2005?
Provide a succinct answer. 1.03. What is the ratio of the Value added (% of GDP) of Japan in 2004 to that in 2005?
Your answer should be compact. 1.09. What is the ratio of the Value added (% of GDP) in Montenegro in 2004 to that in 2005?
Provide a succinct answer. 1.04. What is the ratio of the Value added (% of GDP) in Bangladesh in 2004 to that in 2006?
Make the answer very short. 1.07. What is the ratio of the Value added (% of GDP) of Ecuador in 2004 to that in 2006?
Make the answer very short. 1.05. What is the ratio of the Value added (% of GDP) of Japan in 2004 to that in 2006?
Your answer should be very brief. 1.12. What is the ratio of the Value added (% of GDP) in Montenegro in 2004 to that in 2006?
Provide a short and direct response. 1.07. What is the ratio of the Value added (% of GDP) of Bangladesh in 2004 to that in 2007?
Keep it short and to the point. 1.09. What is the ratio of the Value added (% of GDP) in Ecuador in 2004 to that in 2007?
Provide a succinct answer. 1.05. What is the ratio of the Value added (% of GDP) of Japan in 2004 to that in 2007?
Make the answer very short. 1.15. What is the ratio of the Value added (% of GDP) of Montenegro in 2004 to that in 2007?
Offer a terse response. 1.19. What is the ratio of the Value added (% of GDP) in Bangladesh in 2004 to that in 2008?
Make the answer very short. 1.1. What is the ratio of the Value added (% of GDP) in Ecuador in 2004 to that in 2008?
Keep it short and to the point. 1.12. What is the ratio of the Value added (% of GDP) in Japan in 2004 to that in 2008?
Ensure brevity in your answer.  1.15. What is the ratio of the Value added (% of GDP) of Montenegro in 2004 to that in 2008?
Make the answer very short. 1.17. What is the ratio of the Value added (% of GDP) in Bangladesh in 2004 to that in 2009?
Your answer should be compact. 1.14. What is the ratio of the Value added (% of GDP) in Ecuador in 2004 to that in 2009?
Your answer should be compact. 0.99. What is the ratio of the Value added (% of GDP) in Japan in 2004 to that in 2009?
Make the answer very short. 1.14. What is the ratio of the Value added (% of GDP) of Montenegro in 2004 to that in 2009?
Make the answer very short. 1.09. What is the ratio of the Value added (% of GDP) in Bangladesh in 2005 to that in 2006?
Your response must be concise. 1.03. What is the ratio of the Value added (% of GDP) of Ecuador in 2005 to that in 2006?
Your answer should be compact. 1.01. What is the ratio of the Value added (% of GDP) in Japan in 2005 to that in 2006?
Offer a very short reply. 1.03. What is the ratio of the Value added (% of GDP) in Montenegro in 2005 to that in 2006?
Keep it short and to the point. 1.03. What is the ratio of the Value added (% of GDP) in Bangladesh in 2005 to that in 2007?
Your response must be concise. 1.05. What is the ratio of the Value added (% of GDP) of Ecuador in 2005 to that in 2007?
Offer a very short reply. 1.02. What is the ratio of the Value added (% of GDP) of Japan in 2005 to that in 2007?
Offer a very short reply. 1.06. What is the ratio of the Value added (% of GDP) in Montenegro in 2005 to that in 2007?
Your answer should be compact. 1.15. What is the ratio of the Value added (% of GDP) in Bangladesh in 2005 to that in 2008?
Keep it short and to the point. 1.06. What is the ratio of the Value added (% of GDP) in Ecuador in 2005 to that in 2008?
Offer a terse response. 1.08. What is the ratio of the Value added (% of GDP) of Japan in 2005 to that in 2008?
Your answer should be compact. 1.06. What is the ratio of the Value added (% of GDP) in Montenegro in 2005 to that in 2008?
Make the answer very short. 1.12. What is the ratio of the Value added (% of GDP) in Bangladesh in 2005 to that in 2009?
Keep it short and to the point. 1.1. What is the ratio of the Value added (% of GDP) in Ecuador in 2005 to that in 2009?
Ensure brevity in your answer.  0.96. What is the ratio of the Value added (% of GDP) of Japan in 2005 to that in 2009?
Your answer should be compact. 1.05. What is the ratio of the Value added (% of GDP) in Montenegro in 2005 to that in 2009?
Offer a very short reply. 1.05. What is the ratio of the Value added (% of GDP) of Bangladesh in 2006 to that in 2007?
Your response must be concise. 1.02. What is the ratio of the Value added (% of GDP) of Ecuador in 2006 to that in 2007?
Offer a very short reply. 1.01. What is the ratio of the Value added (% of GDP) of Japan in 2006 to that in 2007?
Ensure brevity in your answer.  1.03. What is the ratio of the Value added (% of GDP) of Montenegro in 2006 to that in 2007?
Make the answer very short. 1.12. What is the ratio of the Value added (% of GDP) in Ecuador in 2006 to that in 2008?
Offer a terse response. 1.06. What is the ratio of the Value added (% of GDP) of Japan in 2006 to that in 2008?
Provide a short and direct response. 1.03. What is the ratio of the Value added (% of GDP) of Montenegro in 2006 to that in 2008?
Ensure brevity in your answer.  1.09. What is the ratio of the Value added (% of GDP) of Bangladesh in 2006 to that in 2009?
Provide a short and direct response. 1.06. What is the ratio of the Value added (% of GDP) in Ecuador in 2006 to that in 2009?
Ensure brevity in your answer.  0.94. What is the ratio of the Value added (% of GDP) of Japan in 2006 to that in 2009?
Keep it short and to the point. 1.02. What is the ratio of the Value added (% of GDP) of Montenegro in 2006 to that in 2009?
Give a very brief answer. 1.02. What is the ratio of the Value added (% of GDP) of Bangladesh in 2007 to that in 2008?
Your response must be concise. 1.01. What is the ratio of the Value added (% of GDP) in Ecuador in 2007 to that in 2008?
Your response must be concise. 1.06. What is the ratio of the Value added (% of GDP) in Montenegro in 2007 to that in 2008?
Offer a very short reply. 0.98. What is the ratio of the Value added (% of GDP) in Bangladesh in 2007 to that in 2009?
Keep it short and to the point. 1.05. What is the ratio of the Value added (% of GDP) in Ecuador in 2007 to that in 2009?
Make the answer very short. 0.94. What is the ratio of the Value added (% of GDP) of Montenegro in 2007 to that in 2009?
Give a very brief answer. 0.91. What is the ratio of the Value added (% of GDP) in Bangladesh in 2008 to that in 2009?
Give a very brief answer. 1.03. What is the ratio of the Value added (% of GDP) of Ecuador in 2008 to that in 2009?
Provide a succinct answer. 0.89. What is the ratio of the Value added (% of GDP) in Japan in 2008 to that in 2009?
Provide a short and direct response. 0.99. What is the ratio of the Value added (% of GDP) in Montenegro in 2008 to that in 2009?
Offer a very short reply. 0.93. What is the difference between the highest and the second highest Value added (% of GDP) in Bangladesh?
Offer a terse response. 0.74. What is the difference between the highest and the second highest Value added (% of GDP) of Ecuador?
Your answer should be compact. 0.56. What is the difference between the highest and the second highest Value added (% of GDP) in Japan?
Ensure brevity in your answer.  0.07. What is the difference between the highest and the second highest Value added (% of GDP) in Montenegro?
Provide a succinct answer. 0.59. What is the difference between the highest and the lowest Value added (% of GDP) of Bangladesh?
Give a very brief answer. 3.8. What is the difference between the highest and the lowest Value added (% of GDP) of Ecuador?
Your answer should be very brief. 2.92. What is the difference between the highest and the lowest Value added (% of GDP) in Japan?
Make the answer very short. 0.32. What is the difference between the highest and the lowest Value added (% of GDP) in Montenegro?
Your answer should be compact. 3.09. 